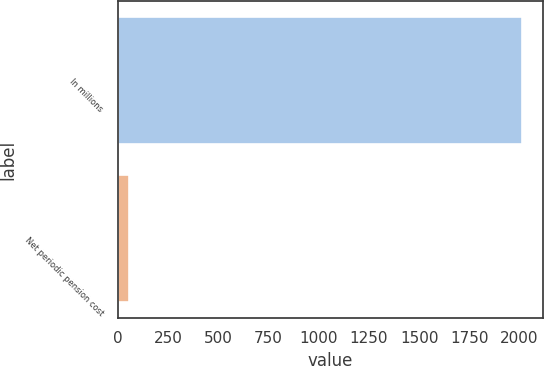<chart> <loc_0><loc_0><loc_500><loc_500><bar_chart><fcel>In millions<fcel>Net periodic pension cost<nl><fcel>2014<fcel>57<nl></chart> 